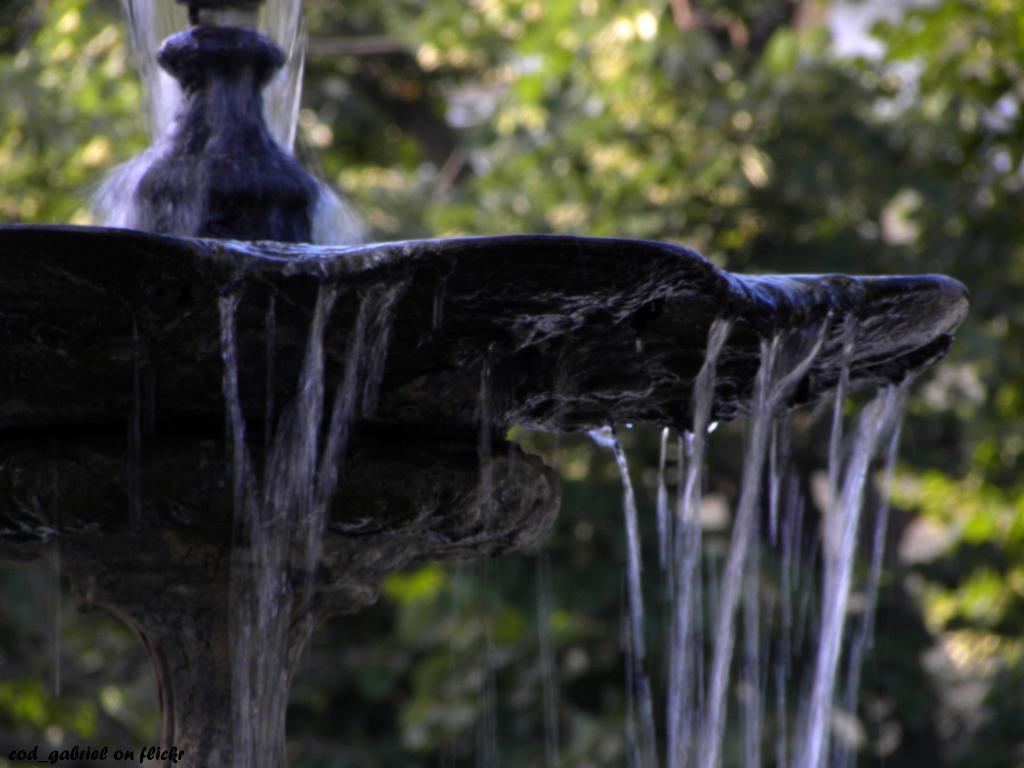Could you give a brief overview of what you see in this image? In this picture we can observe a fountain. There is some water. In the background there are trees. 